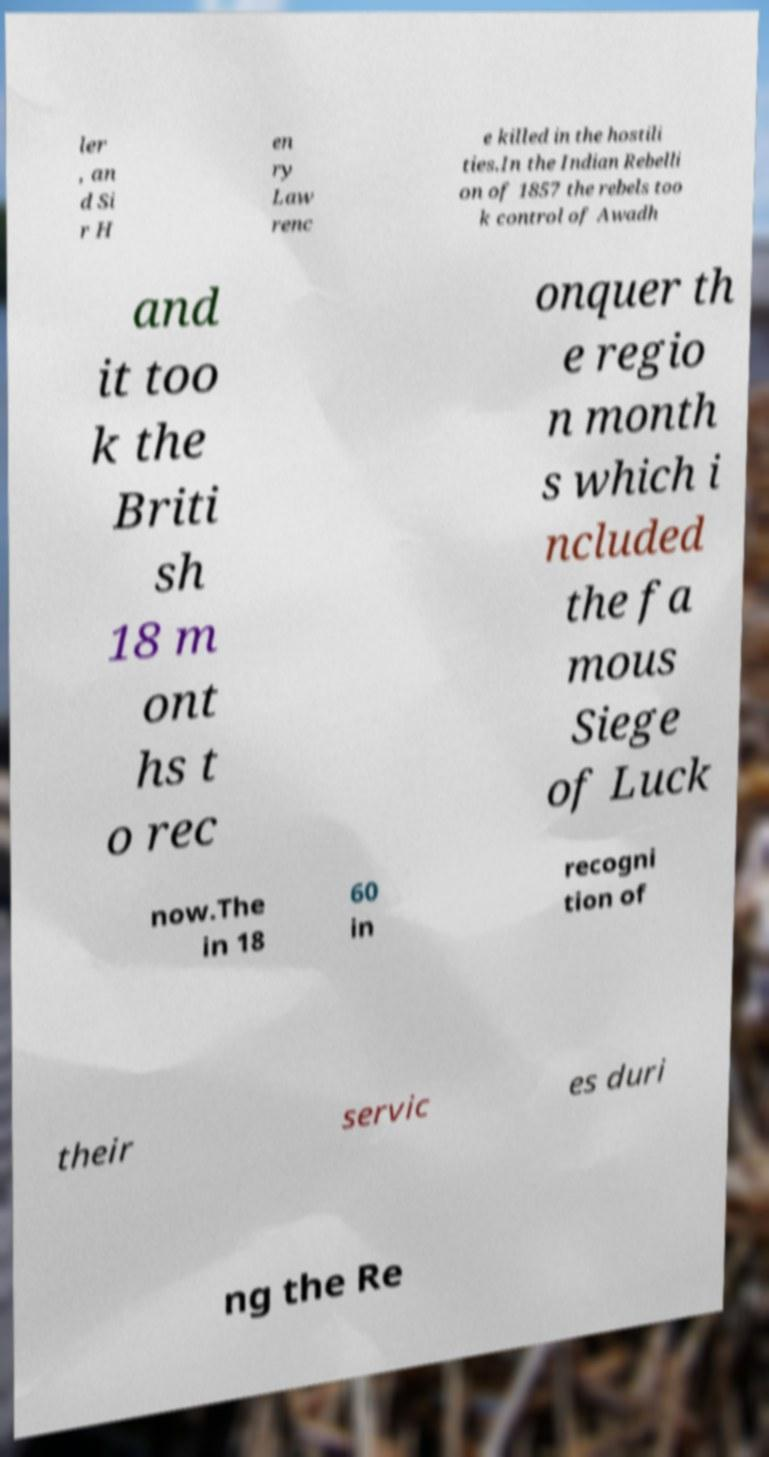Please identify and transcribe the text found in this image. ler , an d Si r H en ry Law renc e killed in the hostili ties.In the Indian Rebelli on of 1857 the rebels too k control of Awadh and it too k the Briti sh 18 m ont hs t o rec onquer th e regio n month s which i ncluded the fa mous Siege of Luck now.The in 18 60 in recogni tion of their servic es duri ng the Re 